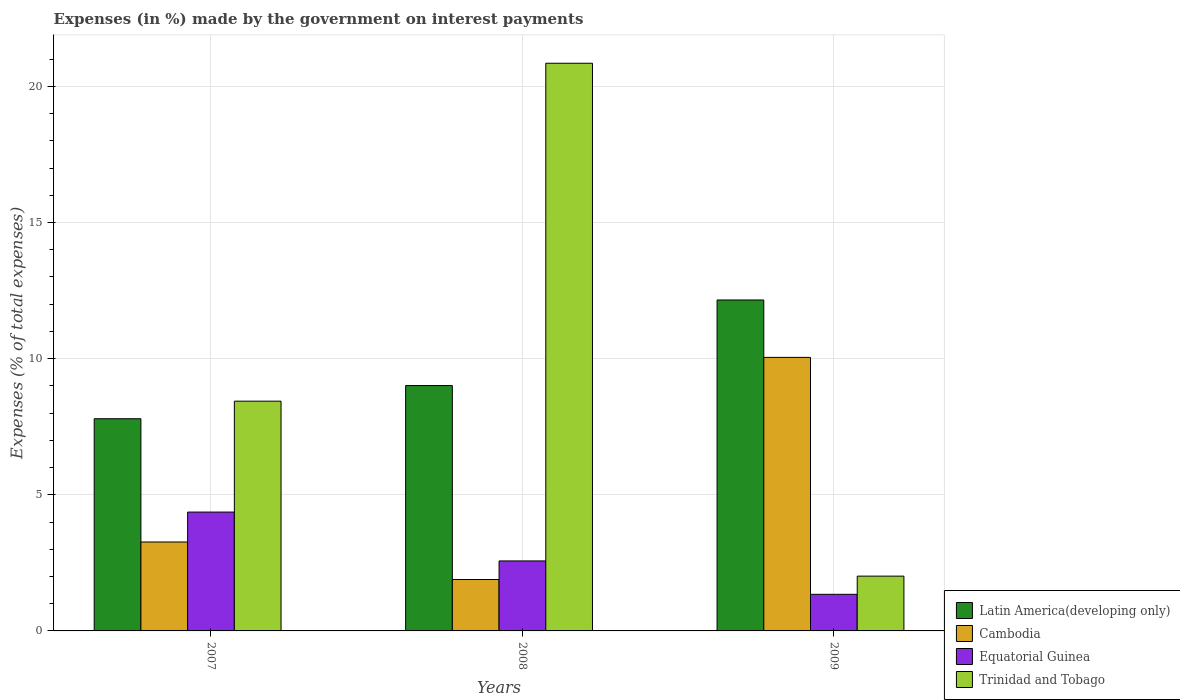How many groups of bars are there?
Make the answer very short. 3. Are the number of bars per tick equal to the number of legend labels?
Your answer should be very brief. Yes. What is the label of the 1st group of bars from the left?
Give a very brief answer. 2007. In how many cases, is the number of bars for a given year not equal to the number of legend labels?
Your answer should be very brief. 0. What is the percentage of expenses made by the government on interest payments in Trinidad and Tobago in 2008?
Your answer should be compact. 20.85. Across all years, what is the maximum percentage of expenses made by the government on interest payments in Equatorial Guinea?
Offer a very short reply. 4.36. Across all years, what is the minimum percentage of expenses made by the government on interest payments in Cambodia?
Your response must be concise. 1.89. In which year was the percentage of expenses made by the government on interest payments in Trinidad and Tobago minimum?
Provide a succinct answer. 2009. What is the total percentage of expenses made by the government on interest payments in Trinidad and Tobago in the graph?
Your answer should be compact. 31.3. What is the difference between the percentage of expenses made by the government on interest payments in Cambodia in 2007 and that in 2009?
Provide a succinct answer. -6.78. What is the difference between the percentage of expenses made by the government on interest payments in Trinidad and Tobago in 2007 and the percentage of expenses made by the government on interest payments in Cambodia in 2008?
Your response must be concise. 6.55. What is the average percentage of expenses made by the government on interest payments in Equatorial Guinea per year?
Give a very brief answer. 2.76. In the year 2007, what is the difference between the percentage of expenses made by the government on interest payments in Equatorial Guinea and percentage of expenses made by the government on interest payments in Trinidad and Tobago?
Provide a short and direct response. -4.07. In how many years, is the percentage of expenses made by the government on interest payments in Trinidad and Tobago greater than 20 %?
Provide a succinct answer. 1. What is the ratio of the percentage of expenses made by the government on interest payments in Cambodia in 2007 to that in 2009?
Offer a very short reply. 0.33. Is the difference between the percentage of expenses made by the government on interest payments in Equatorial Guinea in 2007 and 2008 greater than the difference between the percentage of expenses made by the government on interest payments in Trinidad and Tobago in 2007 and 2008?
Your answer should be very brief. Yes. What is the difference between the highest and the second highest percentage of expenses made by the government on interest payments in Cambodia?
Make the answer very short. 6.78. What is the difference between the highest and the lowest percentage of expenses made by the government on interest payments in Equatorial Guinea?
Keep it short and to the point. 3.02. What does the 4th bar from the left in 2009 represents?
Your response must be concise. Trinidad and Tobago. What does the 1st bar from the right in 2007 represents?
Ensure brevity in your answer.  Trinidad and Tobago. How many years are there in the graph?
Keep it short and to the point. 3. Does the graph contain grids?
Your answer should be very brief. Yes. Where does the legend appear in the graph?
Offer a very short reply. Bottom right. What is the title of the graph?
Keep it short and to the point. Expenses (in %) made by the government on interest payments. Does "Norway" appear as one of the legend labels in the graph?
Offer a terse response. No. What is the label or title of the X-axis?
Provide a succinct answer. Years. What is the label or title of the Y-axis?
Offer a very short reply. Expenses (% of total expenses). What is the Expenses (% of total expenses) of Latin America(developing only) in 2007?
Provide a succinct answer. 7.79. What is the Expenses (% of total expenses) in Cambodia in 2007?
Keep it short and to the point. 3.27. What is the Expenses (% of total expenses) in Equatorial Guinea in 2007?
Make the answer very short. 4.36. What is the Expenses (% of total expenses) of Trinidad and Tobago in 2007?
Give a very brief answer. 8.44. What is the Expenses (% of total expenses) in Latin America(developing only) in 2008?
Offer a terse response. 9.01. What is the Expenses (% of total expenses) in Cambodia in 2008?
Keep it short and to the point. 1.89. What is the Expenses (% of total expenses) in Equatorial Guinea in 2008?
Ensure brevity in your answer.  2.57. What is the Expenses (% of total expenses) of Trinidad and Tobago in 2008?
Provide a succinct answer. 20.85. What is the Expenses (% of total expenses) of Latin America(developing only) in 2009?
Make the answer very short. 12.15. What is the Expenses (% of total expenses) of Cambodia in 2009?
Keep it short and to the point. 10.04. What is the Expenses (% of total expenses) in Equatorial Guinea in 2009?
Offer a very short reply. 1.34. What is the Expenses (% of total expenses) in Trinidad and Tobago in 2009?
Offer a very short reply. 2.01. Across all years, what is the maximum Expenses (% of total expenses) of Latin America(developing only)?
Your answer should be very brief. 12.15. Across all years, what is the maximum Expenses (% of total expenses) of Cambodia?
Make the answer very short. 10.04. Across all years, what is the maximum Expenses (% of total expenses) of Equatorial Guinea?
Provide a succinct answer. 4.36. Across all years, what is the maximum Expenses (% of total expenses) of Trinidad and Tobago?
Offer a very short reply. 20.85. Across all years, what is the minimum Expenses (% of total expenses) of Latin America(developing only)?
Your answer should be very brief. 7.79. Across all years, what is the minimum Expenses (% of total expenses) of Cambodia?
Ensure brevity in your answer.  1.89. Across all years, what is the minimum Expenses (% of total expenses) of Equatorial Guinea?
Your answer should be very brief. 1.34. Across all years, what is the minimum Expenses (% of total expenses) of Trinidad and Tobago?
Give a very brief answer. 2.01. What is the total Expenses (% of total expenses) in Latin America(developing only) in the graph?
Your answer should be very brief. 28.96. What is the total Expenses (% of total expenses) of Cambodia in the graph?
Provide a succinct answer. 15.2. What is the total Expenses (% of total expenses) of Equatorial Guinea in the graph?
Make the answer very short. 8.28. What is the total Expenses (% of total expenses) in Trinidad and Tobago in the graph?
Give a very brief answer. 31.3. What is the difference between the Expenses (% of total expenses) of Latin America(developing only) in 2007 and that in 2008?
Provide a succinct answer. -1.22. What is the difference between the Expenses (% of total expenses) of Cambodia in 2007 and that in 2008?
Make the answer very short. 1.38. What is the difference between the Expenses (% of total expenses) of Equatorial Guinea in 2007 and that in 2008?
Your answer should be very brief. 1.79. What is the difference between the Expenses (% of total expenses) of Trinidad and Tobago in 2007 and that in 2008?
Give a very brief answer. -12.41. What is the difference between the Expenses (% of total expenses) of Latin America(developing only) in 2007 and that in 2009?
Your answer should be very brief. -4.36. What is the difference between the Expenses (% of total expenses) in Cambodia in 2007 and that in 2009?
Provide a succinct answer. -6.78. What is the difference between the Expenses (% of total expenses) in Equatorial Guinea in 2007 and that in 2009?
Offer a very short reply. 3.02. What is the difference between the Expenses (% of total expenses) of Trinidad and Tobago in 2007 and that in 2009?
Make the answer very short. 6.43. What is the difference between the Expenses (% of total expenses) in Latin America(developing only) in 2008 and that in 2009?
Offer a terse response. -3.14. What is the difference between the Expenses (% of total expenses) in Cambodia in 2008 and that in 2009?
Ensure brevity in your answer.  -8.16. What is the difference between the Expenses (% of total expenses) of Equatorial Guinea in 2008 and that in 2009?
Give a very brief answer. 1.23. What is the difference between the Expenses (% of total expenses) in Trinidad and Tobago in 2008 and that in 2009?
Make the answer very short. 18.84. What is the difference between the Expenses (% of total expenses) in Latin America(developing only) in 2007 and the Expenses (% of total expenses) in Cambodia in 2008?
Your response must be concise. 5.9. What is the difference between the Expenses (% of total expenses) in Latin America(developing only) in 2007 and the Expenses (% of total expenses) in Equatorial Guinea in 2008?
Your response must be concise. 5.22. What is the difference between the Expenses (% of total expenses) in Latin America(developing only) in 2007 and the Expenses (% of total expenses) in Trinidad and Tobago in 2008?
Make the answer very short. -13.05. What is the difference between the Expenses (% of total expenses) of Cambodia in 2007 and the Expenses (% of total expenses) of Equatorial Guinea in 2008?
Your answer should be compact. 0.7. What is the difference between the Expenses (% of total expenses) in Cambodia in 2007 and the Expenses (% of total expenses) in Trinidad and Tobago in 2008?
Your answer should be compact. -17.58. What is the difference between the Expenses (% of total expenses) in Equatorial Guinea in 2007 and the Expenses (% of total expenses) in Trinidad and Tobago in 2008?
Ensure brevity in your answer.  -16.48. What is the difference between the Expenses (% of total expenses) of Latin America(developing only) in 2007 and the Expenses (% of total expenses) of Cambodia in 2009?
Make the answer very short. -2.25. What is the difference between the Expenses (% of total expenses) of Latin America(developing only) in 2007 and the Expenses (% of total expenses) of Equatorial Guinea in 2009?
Offer a very short reply. 6.45. What is the difference between the Expenses (% of total expenses) of Latin America(developing only) in 2007 and the Expenses (% of total expenses) of Trinidad and Tobago in 2009?
Make the answer very short. 5.78. What is the difference between the Expenses (% of total expenses) of Cambodia in 2007 and the Expenses (% of total expenses) of Equatorial Guinea in 2009?
Your answer should be compact. 1.92. What is the difference between the Expenses (% of total expenses) of Cambodia in 2007 and the Expenses (% of total expenses) of Trinidad and Tobago in 2009?
Make the answer very short. 1.25. What is the difference between the Expenses (% of total expenses) in Equatorial Guinea in 2007 and the Expenses (% of total expenses) in Trinidad and Tobago in 2009?
Your answer should be very brief. 2.35. What is the difference between the Expenses (% of total expenses) in Latin America(developing only) in 2008 and the Expenses (% of total expenses) in Cambodia in 2009?
Ensure brevity in your answer.  -1.03. What is the difference between the Expenses (% of total expenses) in Latin America(developing only) in 2008 and the Expenses (% of total expenses) in Equatorial Guinea in 2009?
Give a very brief answer. 7.67. What is the difference between the Expenses (% of total expenses) in Latin America(developing only) in 2008 and the Expenses (% of total expenses) in Trinidad and Tobago in 2009?
Keep it short and to the point. 7. What is the difference between the Expenses (% of total expenses) in Cambodia in 2008 and the Expenses (% of total expenses) in Equatorial Guinea in 2009?
Give a very brief answer. 0.54. What is the difference between the Expenses (% of total expenses) of Cambodia in 2008 and the Expenses (% of total expenses) of Trinidad and Tobago in 2009?
Make the answer very short. -0.12. What is the difference between the Expenses (% of total expenses) of Equatorial Guinea in 2008 and the Expenses (% of total expenses) of Trinidad and Tobago in 2009?
Make the answer very short. 0.56. What is the average Expenses (% of total expenses) in Latin America(developing only) per year?
Offer a very short reply. 9.65. What is the average Expenses (% of total expenses) in Cambodia per year?
Your answer should be compact. 5.07. What is the average Expenses (% of total expenses) of Equatorial Guinea per year?
Your response must be concise. 2.76. What is the average Expenses (% of total expenses) of Trinidad and Tobago per year?
Make the answer very short. 10.43. In the year 2007, what is the difference between the Expenses (% of total expenses) of Latin America(developing only) and Expenses (% of total expenses) of Cambodia?
Offer a terse response. 4.53. In the year 2007, what is the difference between the Expenses (% of total expenses) in Latin America(developing only) and Expenses (% of total expenses) in Equatorial Guinea?
Keep it short and to the point. 3.43. In the year 2007, what is the difference between the Expenses (% of total expenses) in Latin America(developing only) and Expenses (% of total expenses) in Trinidad and Tobago?
Keep it short and to the point. -0.65. In the year 2007, what is the difference between the Expenses (% of total expenses) in Cambodia and Expenses (% of total expenses) in Equatorial Guinea?
Give a very brief answer. -1.1. In the year 2007, what is the difference between the Expenses (% of total expenses) in Cambodia and Expenses (% of total expenses) in Trinidad and Tobago?
Provide a short and direct response. -5.17. In the year 2007, what is the difference between the Expenses (% of total expenses) of Equatorial Guinea and Expenses (% of total expenses) of Trinidad and Tobago?
Give a very brief answer. -4.07. In the year 2008, what is the difference between the Expenses (% of total expenses) in Latin America(developing only) and Expenses (% of total expenses) in Cambodia?
Provide a short and direct response. 7.12. In the year 2008, what is the difference between the Expenses (% of total expenses) in Latin America(developing only) and Expenses (% of total expenses) in Equatorial Guinea?
Provide a short and direct response. 6.44. In the year 2008, what is the difference between the Expenses (% of total expenses) of Latin America(developing only) and Expenses (% of total expenses) of Trinidad and Tobago?
Offer a very short reply. -11.84. In the year 2008, what is the difference between the Expenses (% of total expenses) in Cambodia and Expenses (% of total expenses) in Equatorial Guinea?
Offer a very short reply. -0.68. In the year 2008, what is the difference between the Expenses (% of total expenses) in Cambodia and Expenses (% of total expenses) in Trinidad and Tobago?
Your answer should be very brief. -18.96. In the year 2008, what is the difference between the Expenses (% of total expenses) of Equatorial Guinea and Expenses (% of total expenses) of Trinidad and Tobago?
Keep it short and to the point. -18.28. In the year 2009, what is the difference between the Expenses (% of total expenses) in Latin America(developing only) and Expenses (% of total expenses) in Cambodia?
Make the answer very short. 2.11. In the year 2009, what is the difference between the Expenses (% of total expenses) of Latin America(developing only) and Expenses (% of total expenses) of Equatorial Guinea?
Offer a very short reply. 10.81. In the year 2009, what is the difference between the Expenses (% of total expenses) in Latin America(developing only) and Expenses (% of total expenses) in Trinidad and Tobago?
Offer a terse response. 10.14. In the year 2009, what is the difference between the Expenses (% of total expenses) in Cambodia and Expenses (% of total expenses) in Equatorial Guinea?
Your response must be concise. 8.7. In the year 2009, what is the difference between the Expenses (% of total expenses) in Cambodia and Expenses (% of total expenses) in Trinidad and Tobago?
Your answer should be very brief. 8.03. In the year 2009, what is the difference between the Expenses (% of total expenses) in Equatorial Guinea and Expenses (% of total expenses) in Trinidad and Tobago?
Your answer should be compact. -0.67. What is the ratio of the Expenses (% of total expenses) of Latin America(developing only) in 2007 to that in 2008?
Provide a short and direct response. 0.86. What is the ratio of the Expenses (% of total expenses) of Cambodia in 2007 to that in 2008?
Your response must be concise. 1.73. What is the ratio of the Expenses (% of total expenses) in Equatorial Guinea in 2007 to that in 2008?
Your response must be concise. 1.7. What is the ratio of the Expenses (% of total expenses) in Trinidad and Tobago in 2007 to that in 2008?
Provide a short and direct response. 0.4. What is the ratio of the Expenses (% of total expenses) in Latin America(developing only) in 2007 to that in 2009?
Provide a succinct answer. 0.64. What is the ratio of the Expenses (% of total expenses) of Cambodia in 2007 to that in 2009?
Provide a short and direct response. 0.33. What is the ratio of the Expenses (% of total expenses) in Equatorial Guinea in 2007 to that in 2009?
Give a very brief answer. 3.25. What is the ratio of the Expenses (% of total expenses) in Trinidad and Tobago in 2007 to that in 2009?
Your answer should be very brief. 4.19. What is the ratio of the Expenses (% of total expenses) of Latin America(developing only) in 2008 to that in 2009?
Provide a short and direct response. 0.74. What is the ratio of the Expenses (% of total expenses) of Cambodia in 2008 to that in 2009?
Your response must be concise. 0.19. What is the ratio of the Expenses (% of total expenses) in Equatorial Guinea in 2008 to that in 2009?
Your answer should be compact. 1.91. What is the ratio of the Expenses (% of total expenses) in Trinidad and Tobago in 2008 to that in 2009?
Your answer should be very brief. 10.36. What is the difference between the highest and the second highest Expenses (% of total expenses) of Latin America(developing only)?
Your answer should be compact. 3.14. What is the difference between the highest and the second highest Expenses (% of total expenses) of Cambodia?
Give a very brief answer. 6.78. What is the difference between the highest and the second highest Expenses (% of total expenses) of Equatorial Guinea?
Provide a succinct answer. 1.79. What is the difference between the highest and the second highest Expenses (% of total expenses) of Trinidad and Tobago?
Your answer should be very brief. 12.41. What is the difference between the highest and the lowest Expenses (% of total expenses) in Latin America(developing only)?
Provide a succinct answer. 4.36. What is the difference between the highest and the lowest Expenses (% of total expenses) in Cambodia?
Provide a short and direct response. 8.16. What is the difference between the highest and the lowest Expenses (% of total expenses) in Equatorial Guinea?
Your response must be concise. 3.02. What is the difference between the highest and the lowest Expenses (% of total expenses) of Trinidad and Tobago?
Offer a very short reply. 18.84. 